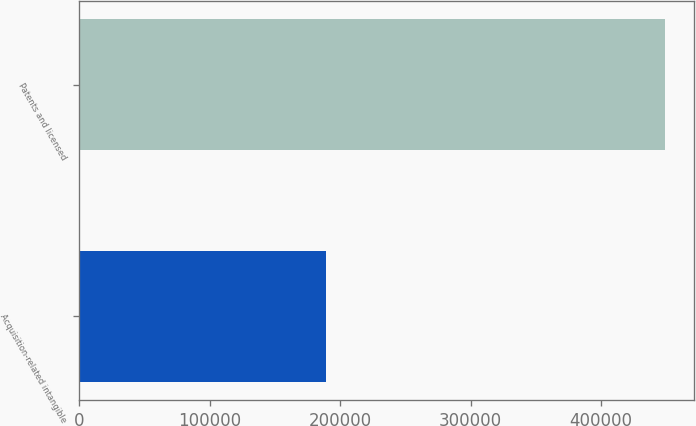Convert chart to OTSL. <chart><loc_0><loc_0><loc_500><loc_500><bar_chart><fcel>Acquisition-related intangible<fcel>Patents and licensed<nl><fcel>189239<fcel>448873<nl></chart> 